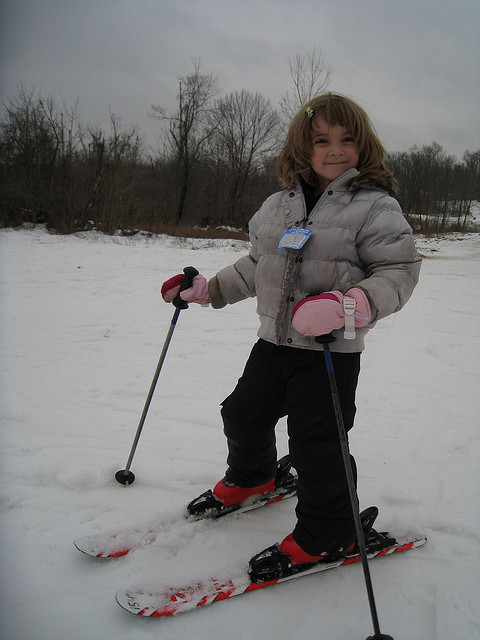Does the little girl like skiing?
Answer the question using a single word or phrase. Yes What color are her mittens? Pink Is this picture taken in North Dakota? No 